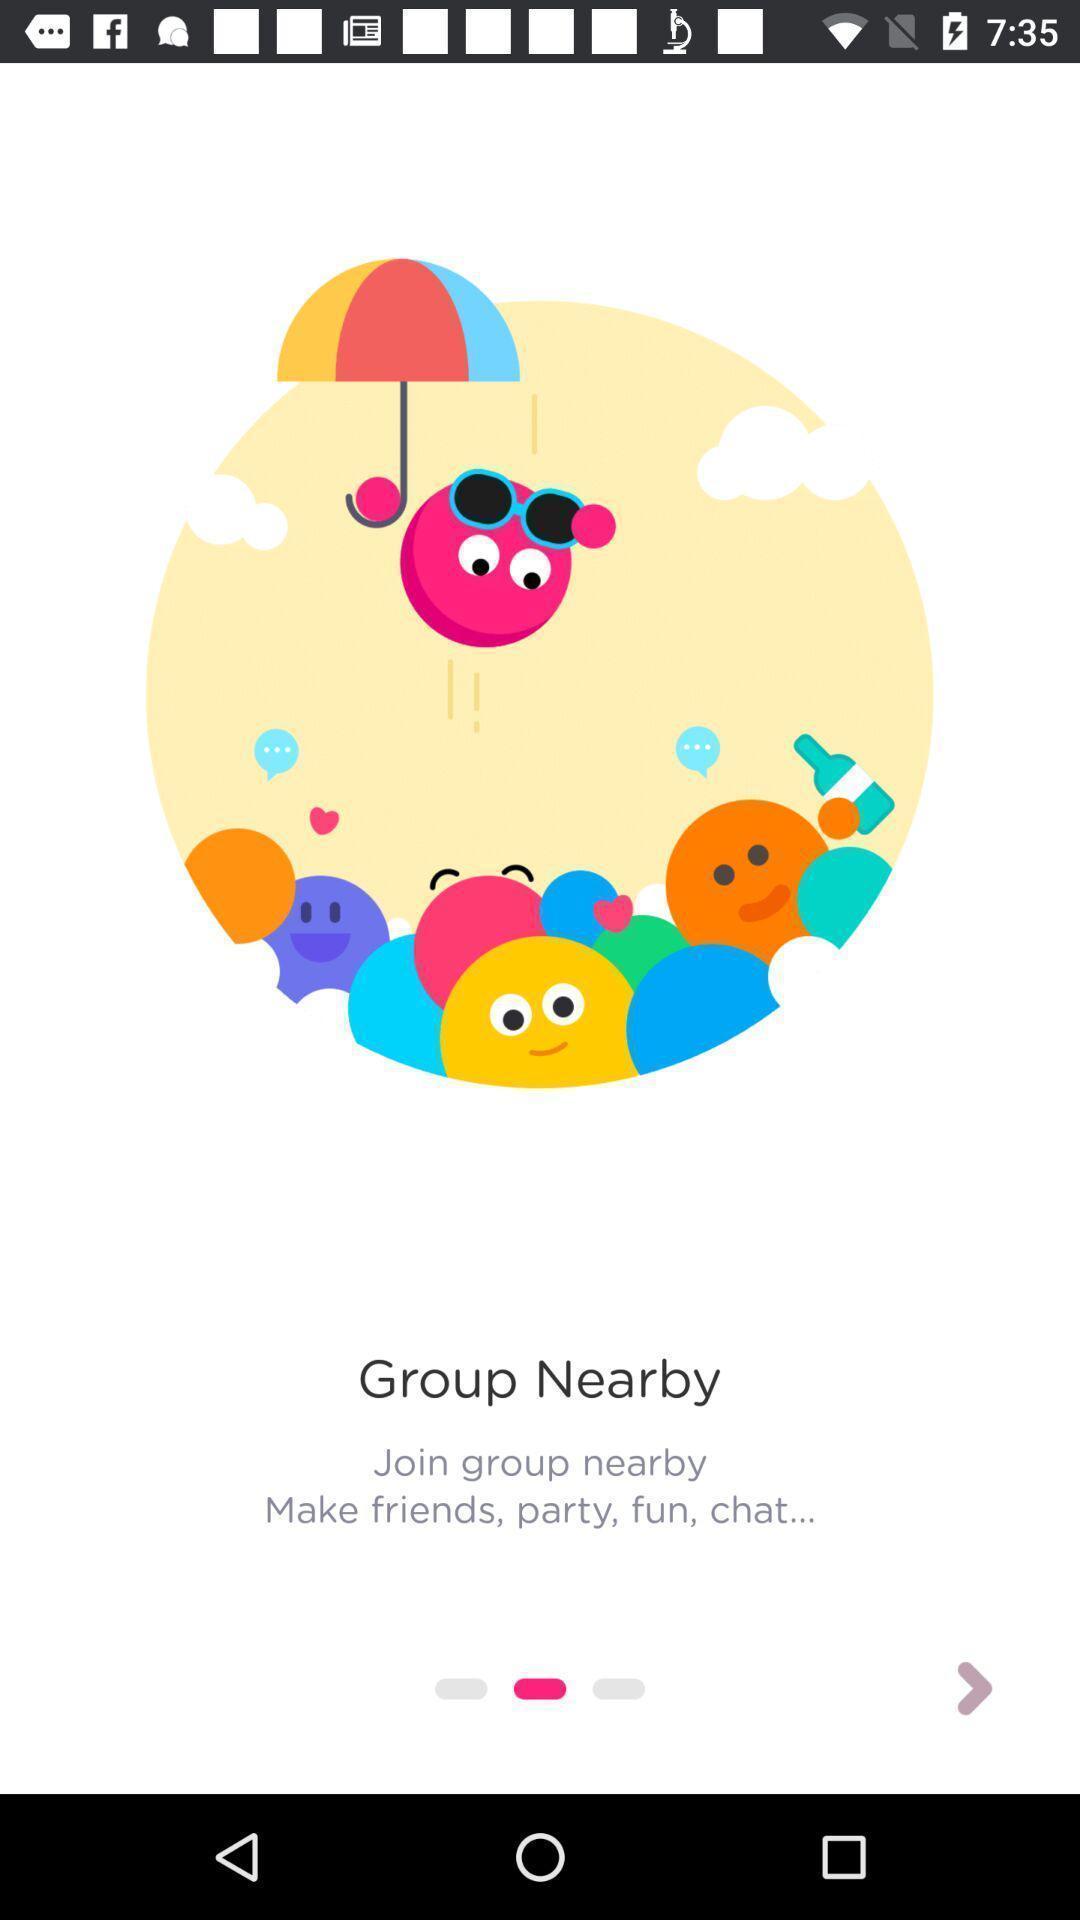Provide a description of this screenshot. Welcome page. 